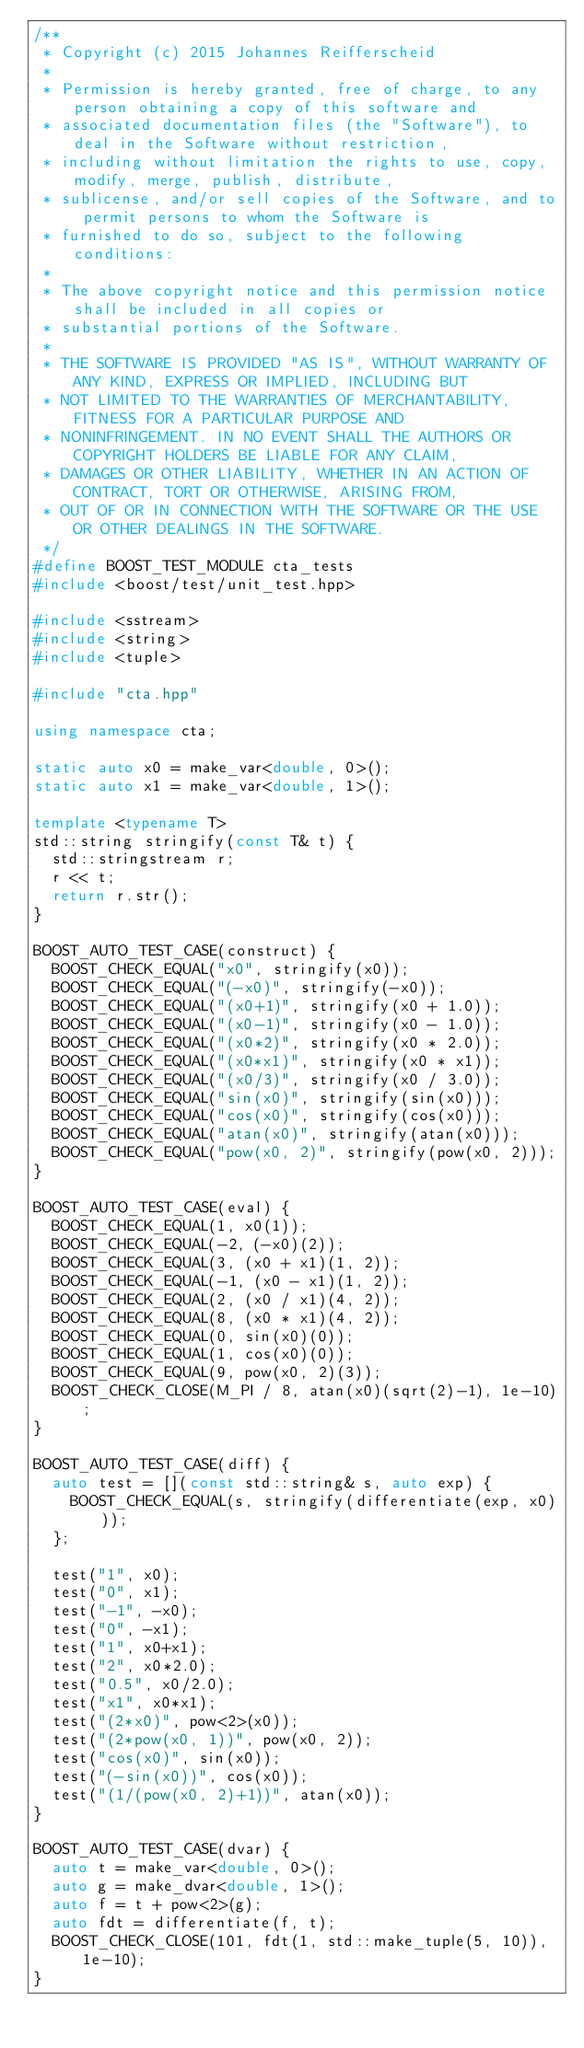<code> <loc_0><loc_0><loc_500><loc_500><_C++_>/**
 * Copyright (c) 2015 Johannes Reifferscheid
 *
 * Permission is hereby granted, free of charge, to any person obtaining a copy of this software and
 * associated documentation files (the "Software"), to deal in the Software without restriction,
 * including without limitation the rights to use, copy, modify, merge, publish, distribute,
 * sublicense, and/or sell copies of the Software, and to permit persons to whom the Software is
 * furnished to do so, subject to the following conditions:
 *
 * The above copyright notice and this permission notice shall be included in all copies or
 * substantial portions of the Software.
 *
 * THE SOFTWARE IS PROVIDED "AS IS", WITHOUT WARRANTY OF ANY KIND, EXPRESS OR IMPLIED, INCLUDING BUT
 * NOT LIMITED TO THE WARRANTIES OF MERCHANTABILITY, FITNESS FOR A PARTICULAR PURPOSE AND
 * NONINFRINGEMENT. IN NO EVENT SHALL THE AUTHORS OR COPYRIGHT HOLDERS BE LIABLE FOR ANY CLAIM,
 * DAMAGES OR OTHER LIABILITY, WHETHER IN AN ACTION OF CONTRACT, TORT OR OTHERWISE, ARISING FROM,
 * OUT OF OR IN CONNECTION WITH THE SOFTWARE OR THE USE OR OTHER DEALINGS IN THE SOFTWARE.
 */
#define BOOST_TEST_MODULE cta_tests
#include <boost/test/unit_test.hpp>

#include <sstream>
#include <string>
#include <tuple>

#include "cta.hpp"

using namespace cta;

static auto x0 = make_var<double, 0>();
static auto x1 = make_var<double, 1>();

template <typename T>
std::string stringify(const T& t) {
	std::stringstream r;
	r << t;
	return r.str();
}

BOOST_AUTO_TEST_CASE(construct) {
	BOOST_CHECK_EQUAL("x0", stringify(x0));
	BOOST_CHECK_EQUAL("(-x0)", stringify(-x0));
	BOOST_CHECK_EQUAL("(x0+1)", stringify(x0 + 1.0));
	BOOST_CHECK_EQUAL("(x0-1)", stringify(x0 - 1.0));
	BOOST_CHECK_EQUAL("(x0*2)", stringify(x0 * 2.0));
	BOOST_CHECK_EQUAL("(x0*x1)", stringify(x0 * x1));
	BOOST_CHECK_EQUAL("(x0/3)", stringify(x0 / 3.0));
	BOOST_CHECK_EQUAL("sin(x0)", stringify(sin(x0)));
	BOOST_CHECK_EQUAL("cos(x0)", stringify(cos(x0)));
	BOOST_CHECK_EQUAL("atan(x0)", stringify(atan(x0)));
	BOOST_CHECK_EQUAL("pow(x0, 2)", stringify(pow(x0, 2)));
}

BOOST_AUTO_TEST_CASE(eval) {
	BOOST_CHECK_EQUAL(1, x0(1));
	BOOST_CHECK_EQUAL(-2, (-x0)(2));
	BOOST_CHECK_EQUAL(3, (x0 + x1)(1, 2));
	BOOST_CHECK_EQUAL(-1, (x0 - x1)(1, 2));
	BOOST_CHECK_EQUAL(2, (x0 / x1)(4, 2));
	BOOST_CHECK_EQUAL(8, (x0 * x1)(4, 2));
	BOOST_CHECK_EQUAL(0, sin(x0)(0));
	BOOST_CHECK_EQUAL(1, cos(x0)(0));
	BOOST_CHECK_EQUAL(9, pow(x0, 2)(3));
	BOOST_CHECK_CLOSE(M_PI / 8, atan(x0)(sqrt(2)-1), 1e-10);
}

BOOST_AUTO_TEST_CASE(diff) {
	auto test = [](const std::string& s, auto exp) {
		BOOST_CHECK_EQUAL(s, stringify(differentiate(exp, x0)));
	};

	test("1", x0);
	test("0", x1);
	test("-1", -x0);
	test("0", -x1);
	test("1", x0+x1);
	test("2", x0*2.0);
	test("0.5", x0/2.0);
	test("x1", x0*x1);
	test("(2*x0)", pow<2>(x0));
	test("(2*pow(x0, 1))", pow(x0, 2));
	test("cos(x0)", sin(x0));
	test("(-sin(x0))", cos(x0));
	test("(1/(pow(x0, 2)+1))", atan(x0));
}

BOOST_AUTO_TEST_CASE(dvar) {
	auto t = make_var<double, 0>();
	auto g = make_dvar<double, 1>();
	auto f = t + pow<2>(g);
	auto fdt = differentiate(f, t);
	BOOST_CHECK_CLOSE(101, fdt(1, std::make_tuple(5, 10)), 1e-10);
}
</code> 